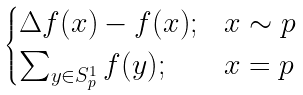Convert formula to latex. <formula><loc_0><loc_0><loc_500><loc_500>\begin{cases} \Delta f ( x ) - f ( x ) ; & x \sim p \\ \sum _ { y \in S ^ { 1 } _ { p } } f ( y ) ; & x = p \\ \end{cases}</formula> 